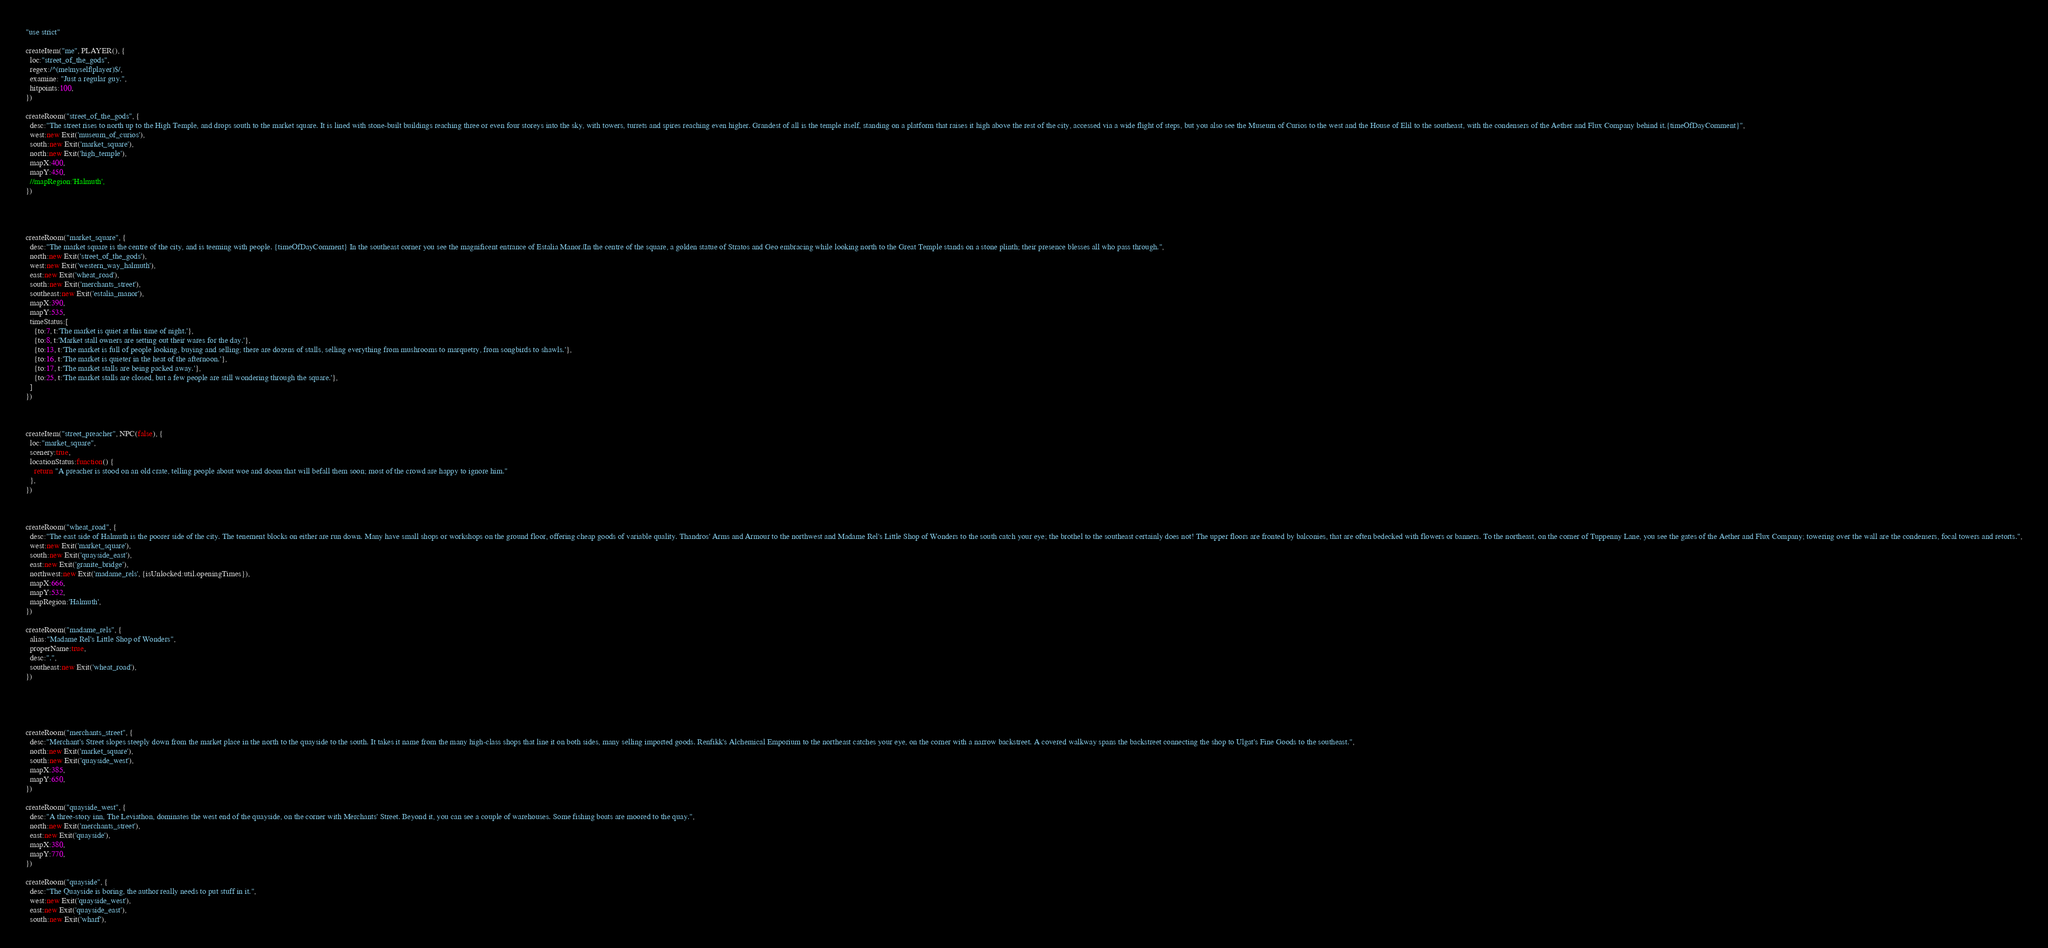<code> <loc_0><loc_0><loc_500><loc_500><_JavaScript_>"use strict"

createItem("me", PLAYER(), {
  loc:"street_of_the_gods",
  regex:/^(me|myself|player)$/,
  examine: "Just a regular guy.",
  hitpoints:100,
})

createRoom("street_of_the_gods", {
  desc:"The street rises to north up to the High Temple, and drops south to the market square. It is lined with stone-built buildings reaching three or even four storeys into the sky, with towers, turrets and spires reaching even higher. Grandest of all is the temple itself, standing on a platform that raises it high above the rest of the city, accessed via a wide flight of steps, but you also see the Museum of Curios to the west and the House of Elil to the southeast, with the condensers of the Aether and Flux Company behind it.{timeOfDayComment}",
  west:new Exit('museum_of_curios'),
  south:new Exit('market_square'),
  north:new Exit('high_temple'),
  mapX:400,
  mapY:450,
  //mapRegion:'Halmuth',
})




createRoom("market_square", {
  desc:"The market square is the centre of the city, and is teeming with people. {timeOfDayComment} In the southeast corner you see the magnificent entrance of Estalia Manor.|In the centre of the square, a golden statue of Stratos and Geo embracing while looking north to the Great Temple stands on a stone plinth; their presence blesses all who pass through.",
  north:new Exit('street_of_the_gods'),
  west:new Exit('western_way_halmuth'),
  east:new Exit('wheat_road'),
  south:new Exit('merchants_street'),
  southeast:new Exit('estalia_manor'),
  mapX:390,
  mapY:535,
  timeStatus:[
    {to:7, t:'The market is quiet at this time of night.'},
    {to:8, t:'Market stall owners are setting out their wares for the day.'},
    {to:13, t:'The market is full of people looking, buying and selling; there are dozens of stalls, selling everything from mushrooms to marquetry, from songbirds to shawls.'},
    {to:16, t:'The market is quieter in the heat of the afternoon.'},
    {to:17, t:'The market stalls are being packed away.'},
    {to:25, t:'The market stalls are closed, but a few people are still wondering through the square.'},
  ]
})



createItem("street_preacher", NPC(false), {
  loc:"market_square",
  scenery:true,
  locationStatus:function() {
    return "A preacher is stood on an old crate, telling people about woe and doom that will befall them soon; most of the crowd are happy to ignore him."
  },
})



createRoom("wheat_road", {
  desc:"The east side of Halmuth is the poorer side of the city. The tenement blocks on either are run down. Many have small shops or workshops on the ground floor, offering cheap goods of variable quality. Thandros' Arms and Armour to the northwest and Madame Rel's Little Shop of Wonders to the south catch your eye; the brothel to the southeast certainly does not! The upper floors are fronted by balconies, that are often bedecked with flowers or banners. To the northeast, on the corner of Tuppenny Lane, you see the gates of the Aether and Flux Company; towering over the wall are the condensers, focal towers and retorts.",
  west:new Exit('market_square'),
  south:new Exit('quayside_east'),
  east:new Exit('granite_bridge'),
  northwest:new Exit('madame_rels', {isUnlocked:util.openingTimes}),
  mapX:666,
  mapY:532,
  mapRegion:'Halmuth',
})

createRoom("madame_rels", {
  alias:"Madame Rel's Little Shop of Wonders",
  properName:true,
  desc:".",
  southeast:new Exit('wheat_road'),
})





createRoom("merchants_street", {
  desc:"Merchant's Street slopes steeply down from the market place in the north to the quayside to the south. It takes it name from the many high-class shops that line it on both sides, many selling imported goods. Renfikk's Alchemical Emporium to the northeast catches your eye, on the corner with a narrow backstreet. A covered walkway spans the backstreet connecting the shop to Ulgat's Fine Goods to the southeast.",
  north:new Exit('market_square'),
  south:new Exit('quayside_west'),
  mapX:385,
  mapY:650,
})

createRoom("quayside_west", {
  desc:"A three-story inn, The Leviathon, dominates the west end of the quayside, on the corner with Merchants' Street. Beyond it, you can see a couple of warehouses. Some fishing boats are moored to the quay.",
  north:new Exit('merchants_street'),
  east:new Exit('quayside'),
  mapX:380,
  mapY:770,
})

createRoom("quayside", {
  desc:"The Quayside is boring, the author really needs to put stuff in it.",
  west:new Exit('quayside_west'),
  east:new Exit('quayside_east'),
  south:new Exit('wharf'),</code> 